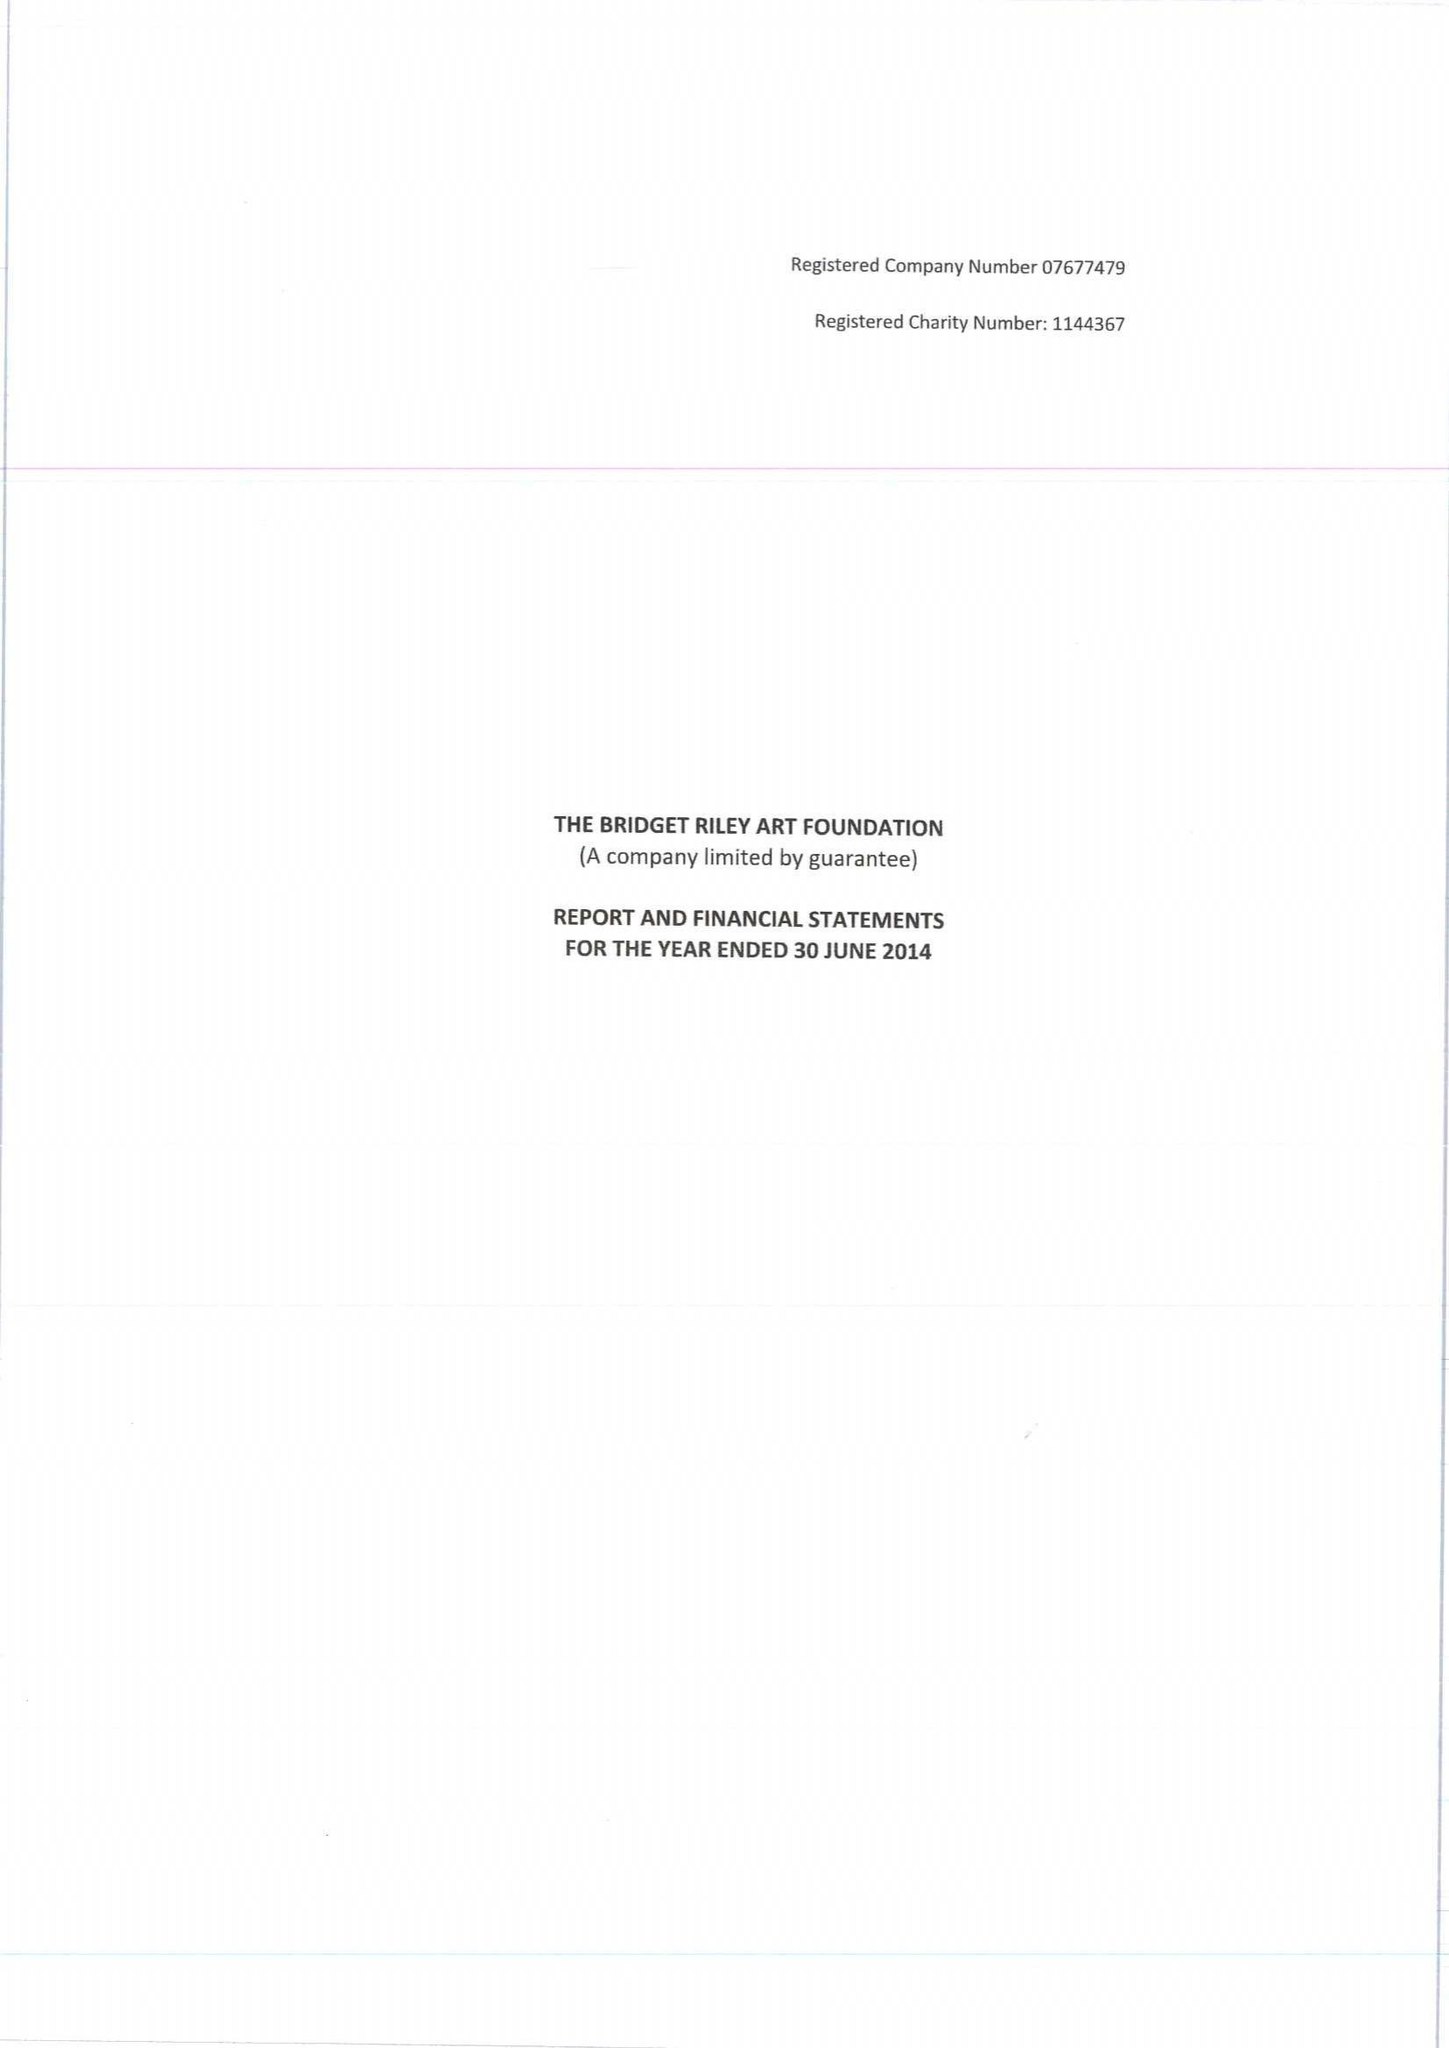What is the value for the charity_name?
Answer the question using a single word or phrase. The Bridget Riley Art Foundation 